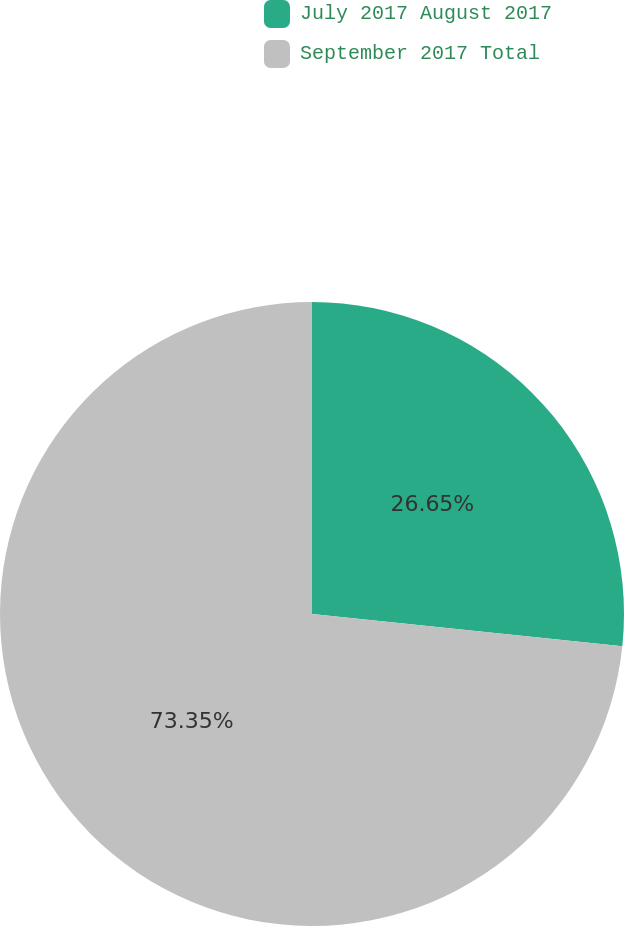Convert chart to OTSL. <chart><loc_0><loc_0><loc_500><loc_500><pie_chart><fcel>July 2017 August 2017<fcel>September 2017 Total<nl><fcel>26.65%<fcel>73.35%<nl></chart> 